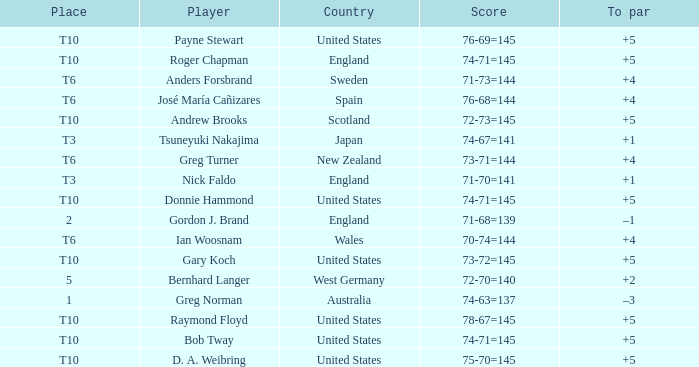What is Greg Norman's place? 1.0. Can you give me this table as a dict? {'header': ['Place', 'Player', 'Country', 'Score', 'To par'], 'rows': [['T10', 'Payne Stewart', 'United States', '76-69=145', '+5'], ['T10', 'Roger Chapman', 'England', '74-71=145', '+5'], ['T6', 'Anders Forsbrand', 'Sweden', '71-73=144', '+4'], ['T6', 'José María Cañizares', 'Spain', '76-68=144', '+4'], ['T10', 'Andrew Brooks', 'Scotland', '72-73=145', '+5'], ['T3', 'Tsuneyuki Nakajima', 'Japan', '74-67=141', '+1'], ['T6', 'Greg Turner', 'New Zealand', '73-71=144', '+4'], ['T3', 'Nick Faldo', 'England', '71-70=141', '+1'], ['T10', 'Donnie Hammond', 'United States', '74-71=145', '+5'], ['2', 'Gordon J. Brand', 'England', '71-68=139', '–1'], ['T6', 'Ian Woosnam', 'Wales', '70-74=144', '+4'], ['T10', 'Gary Koch', 'United States', '73-72=145', '+5'], ['5', 'Bernhard Langer', 'West Germany', '72-70=140', '+2'], ['1', 'Greg Norman', 'Australia', '74-63=137', '–3'], ['T10', 'Raymond Floyd', 'United States', '78-67=145', '+5'], ['T10', 'Bob Tway', 'United States', '74-71=145', '+5'], ['T10', 'D. A. Weibring', 'United States', '75-70=145', '+5']]} 